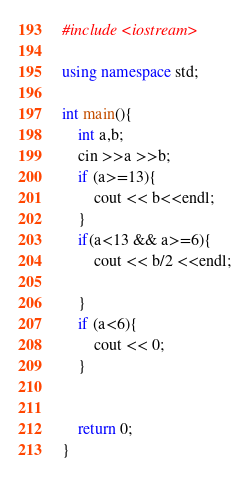<code> <loc_0><loc_0><loc_500><loc_500><_C++_>#include <iostream>

using namespace std;

int main(){
    int a,b;
    cin >>a >>b;
    if (a>=13){
        cout << b<<endl;
    }
    if(a<13 && a>=6){
        cout << b/2 <<endl;

    }
    if (a<6){
        cout << 0;
    }


    return 0;
}
</code> 